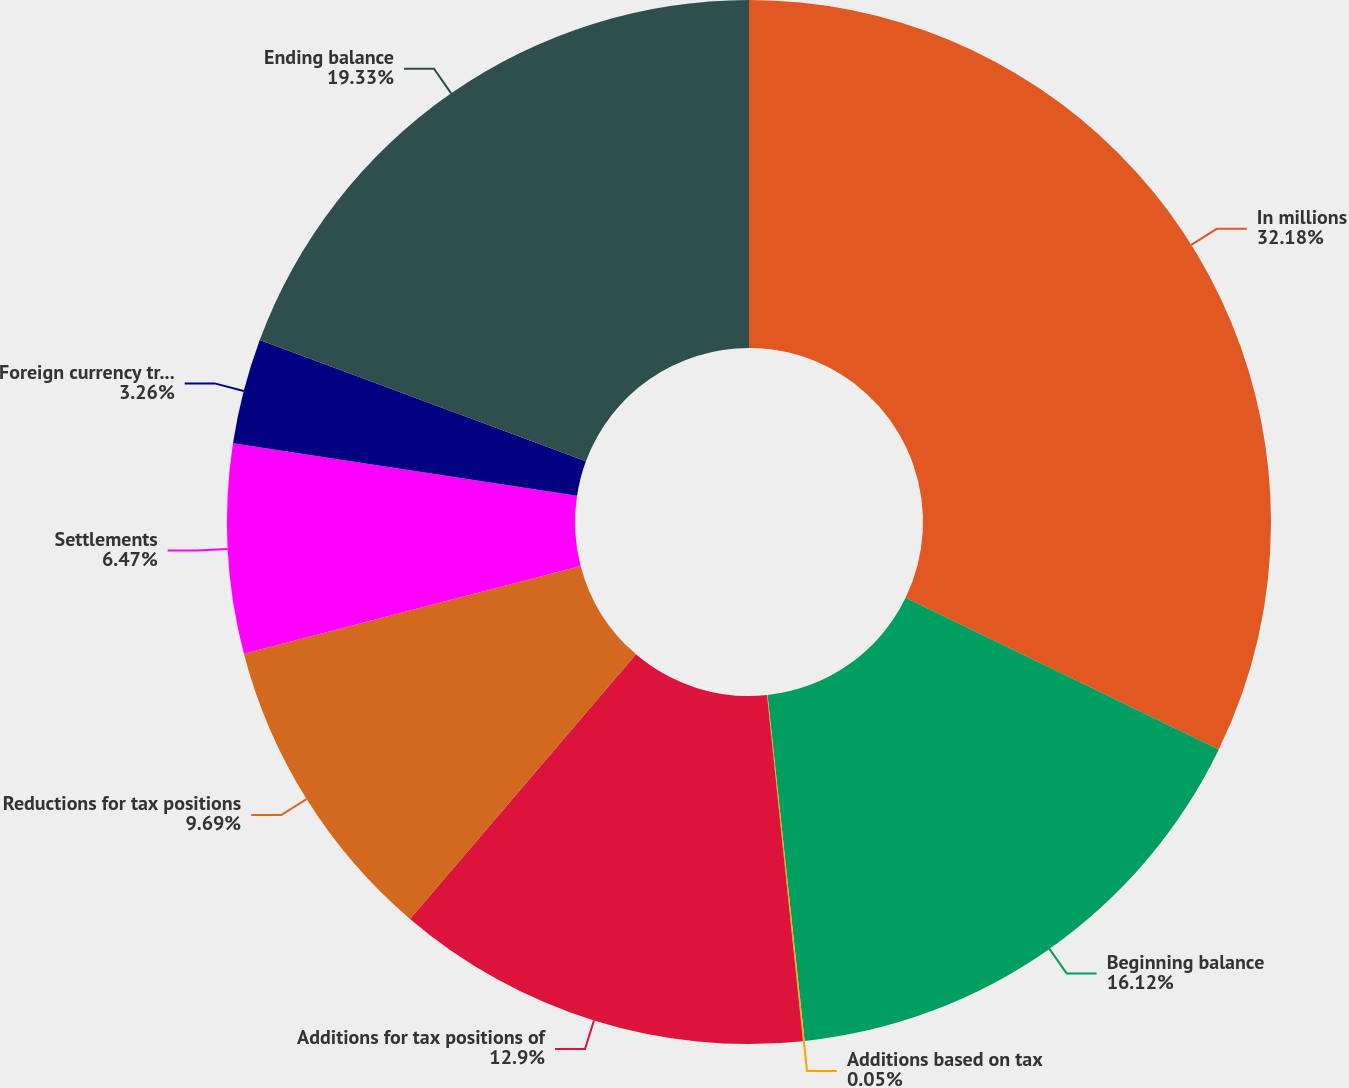Convert chart. <chart><loc_0><loc_0><loc_500><loc_500><pie_chart><fcel>In millions<fcel>Beginning balance<fcel>Additions based on tax<fcel>Additions for tax positions of<fcel>Reductions for tax positions<fcel>Settlements<fcel>Foreign currency translation<fcel>Ending balance<nl><fcel>32.18%<fcel>16.12%<fcel>0.05%<fcel>12.9%<fcel>9.69%<fcel>6.47%<fcel>3.26%<fcel>19.33%<nl></chart> 